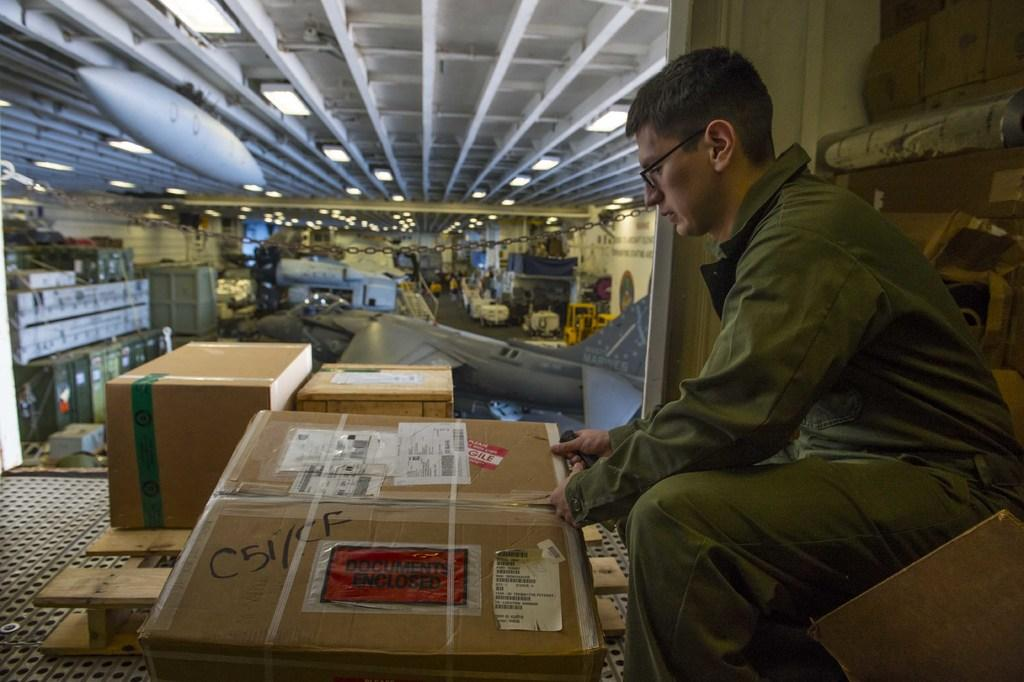<image>
Write a terse but informative summary of the picture. A worker handles a cardboard box which has documents enclosed. 